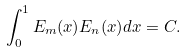<formula> <loc_0><loc_0><loc_500><loc_500>\int _ { 0 } ^ { 1 } E _ { m } ( x ) E _ { n } ( x ) d x = C .</formula> 